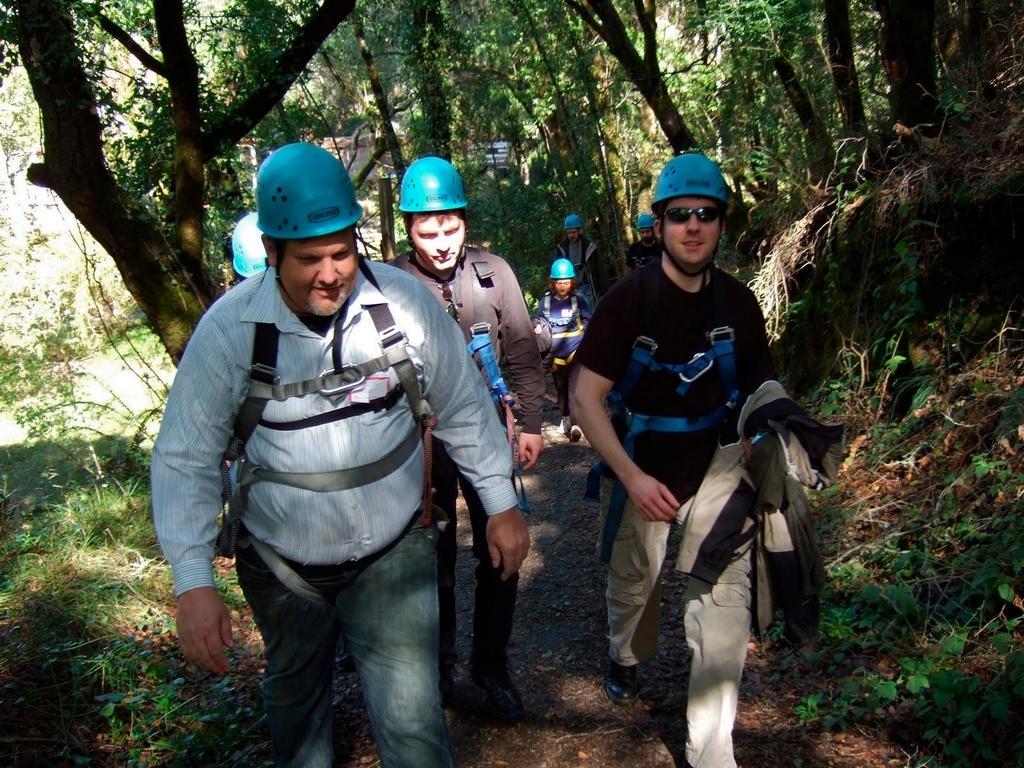In one or two sentences, can you explain what this image depicts? In the picture we can see these people wearing blue color helmets and dresses are walking on the road. Here we can see the grass and trees on the either side of the image. 